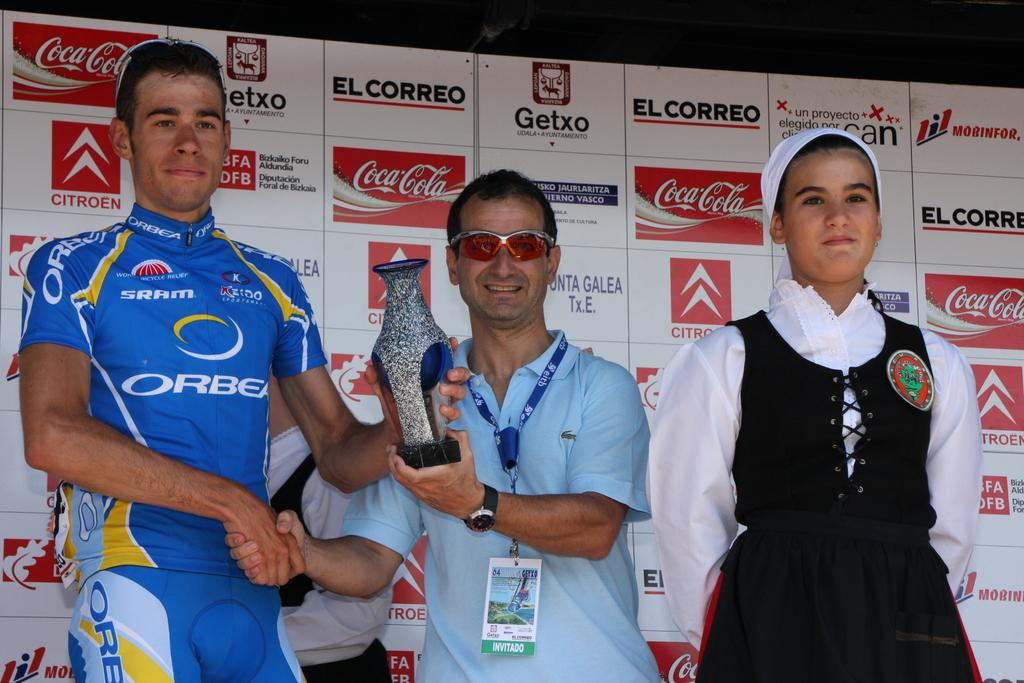<image>
Summarize the visual content of the image. Two men shake hands with one wearing a blue Orbea jersey while a woman looks on. 